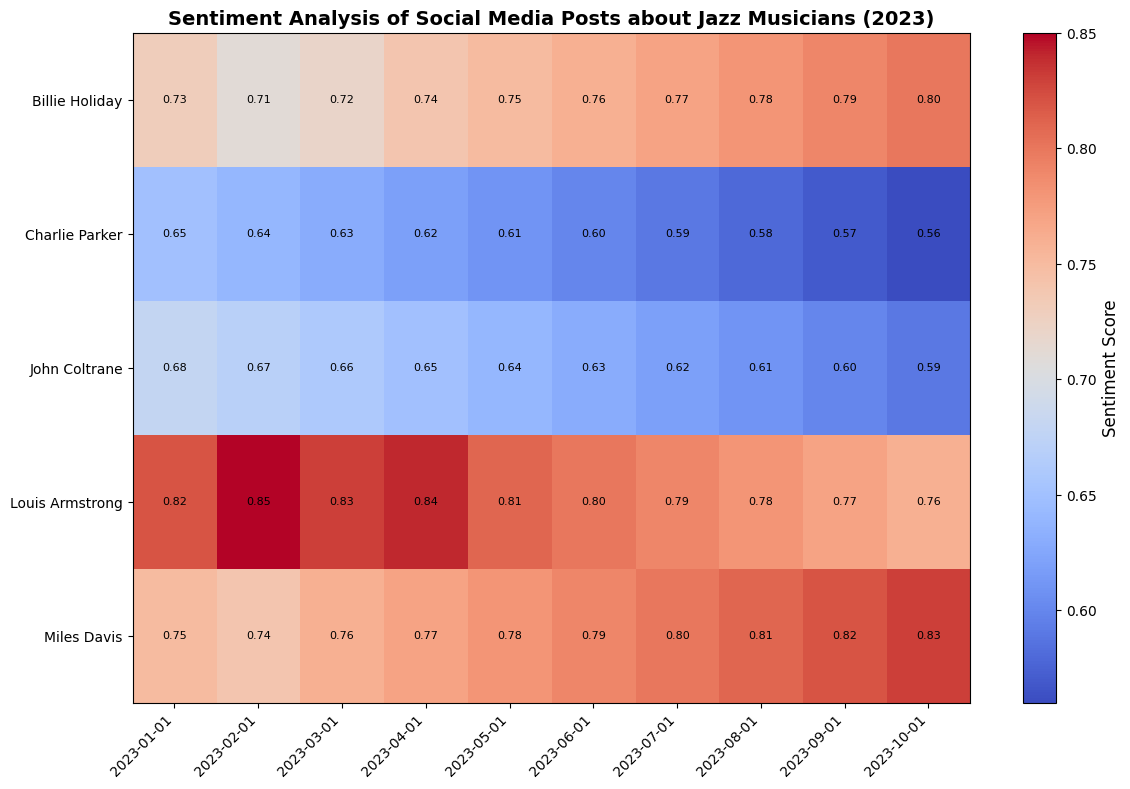Which musician has the highest sentiment score in January 2023? By checking the sentiment scores for January 2023 in the first column, Louis Armstrong has the highest sentiment score of 0.82.
Answer: Louis Armstrong What is the trend of Miles Davis's sentiment score from January to October 2023? Look at the sentiment scores for Miles Davis across the columns; they consistently increase from 0.75 in January to 0.83 in October.
Answer: Increasing Between John Coltrane and Charlie Parker, who had a lower sentiment score in October 2023? Compare the sentiment scores for both musicians in October 2023; John Coltrane has 0.59, and Charlie Parker has 0.56. Therefore, Charlie Parker has the lower score.
Answer: Charlie Parker How does Billie Holiday's sentiment score in March 2023 compare to her score in September 2023? Billie Holiday's sentiment score was 0.72 in March 2023 and 0.79 in September 2023, showing an increase.
Answer: It increased Which month shows the highest sentiment score for Billie Holiday? The highest sentiment score for Billie Holiday across the months is 0.80, which occurs in October 2023.
Answer: October 2023 Which jazz musician's sentiment score has consistently decreased over the months? Review the sentiment scores of each musician to identify a consistent decrease; Charlie Parker's sentiment score decreases from 0.65 in January to 0.56 in October.
Answer: Charlie Parker What is the median sentiment score for John Coltrane over the year indicated in the heatmap? The sentiment scores for John Coltrane are 0.68, 0.67, 0.66, 0.65, 0.64, 0.63, 0.62, 0.61, 0.60, and 0.59. The median is the middle value, which in this case (sorted) is 0.635.
Answer: 0.635 Compare the sentiment scores of Louis Armstrong and John Coltrane in June 2023. Who has a higher score? Louis Armstrong's sentiment score in June is 0.80, and John Coltrane's score is 0.63. Hence, Louis Armstrong has a higher score.
Answer: Louis Armstrong What is the general color trend of the heatmap for Miles Davis's sentiment score as the months progress? Observing the heatmap, the color for Miles Davis goes from a lighter shade (yellow-red) in January towards a darker red as the months progress, indicating higher sentiment scores.
Answer: Darkening 